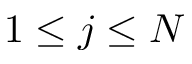<formula> <loc_0><loc_0><loc_500><loc_500>1 \leq j \leq N</formula> 